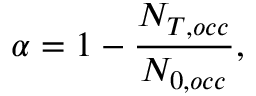Convert formula to latex. <formula><loc_0><loc_0><loc_500><loc_500>\alpha = 1 - \frac { N _ { T , o c c } } { N _ { 0 , o c c } } ,</formula> 